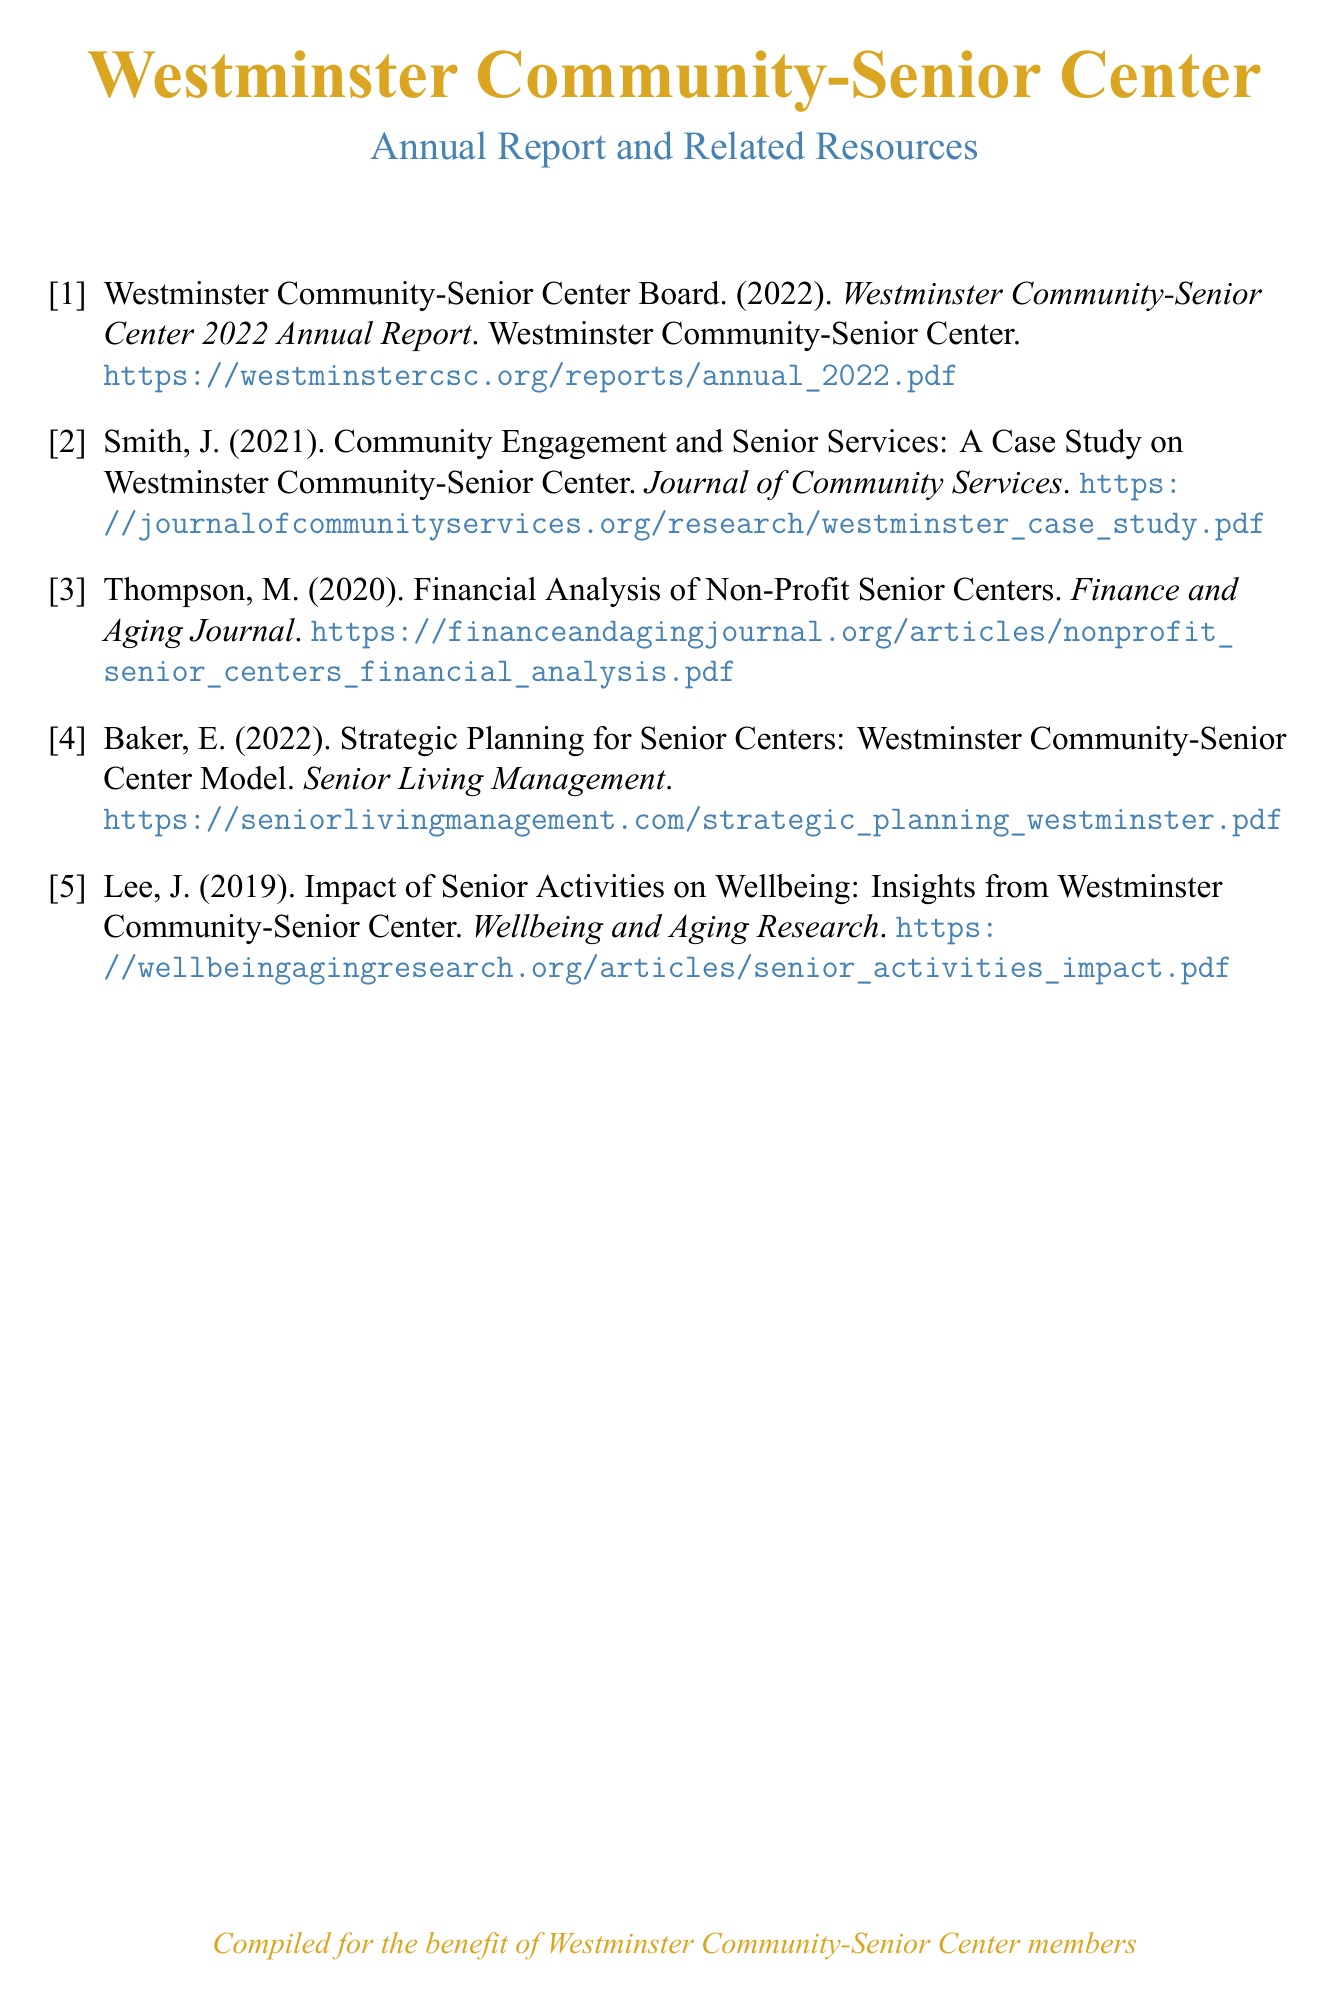What is the title of the 2022 report? The title can be found in the bibliography and it is the official title given to the annual report for that year.
Answer: Westminster Community-Senior Center 2022 Annual Report Who authored the report in 2022? The author can be identified in the citation information listed in the document.
Answer: Westminster Community-Senior Center Board What year was the financial analysis published? The publication year is indicated in the citation details of the bibliography.
Answer: 2020 What is the focus of Smith's 2021 publication? The focus is specified in the title of the cited work, which provides an overview of Smith's case study led on community engagement.
Answer: Community Engagement and Senior Services How many publications are listed in the bibliography? The number of entries provided in the bibliography section indicates the total published works cited.
Answer: 5 What subject does Baker's 2022 publication address? The subject is highlighted in the title of Baker's work, which emphasizes strategic planning within the context of senior centers.
Answer: Strategic Planning for Senior Centers Which publication discusses senior activities' impact on wellbeing? The specific title can be found in the bibliography and relates to the work's subject matter.
Answer: Impact of Senior Activities on Wellbeing What type of document is this? The classification is established by the structure and content of the text presented as a collection of citations.
Answer: Bibliography 